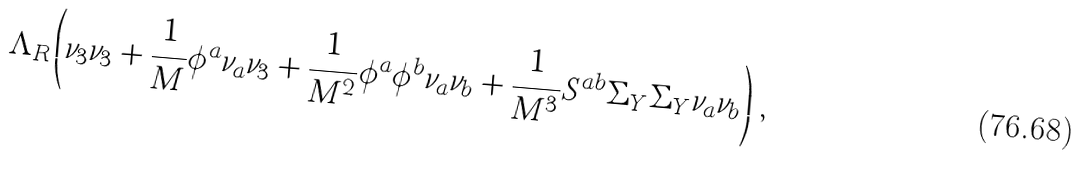Convert formula to latex. <formula><loc_0><loc_0><loc_500><loc_500>\Lambda _ { R } \left ( \nu _ { 3 } \nu _ { 3 } + \frac { 1 } { M } \phi ^ { a } \nu _ { a } \nu _ { 3 } + \frac { 1 } { M ^ { 2 } } \phi ^ { a } \phi ^ { b } \nu _ { a } \nu _ { b } + \frac { 1 } { M ^ { 3 } } S ^ { a b } \Sigma _ { Y } \Sigma _ { Y } \nu _ { a } \nu _ { b } \right ) \, ,</formula> 